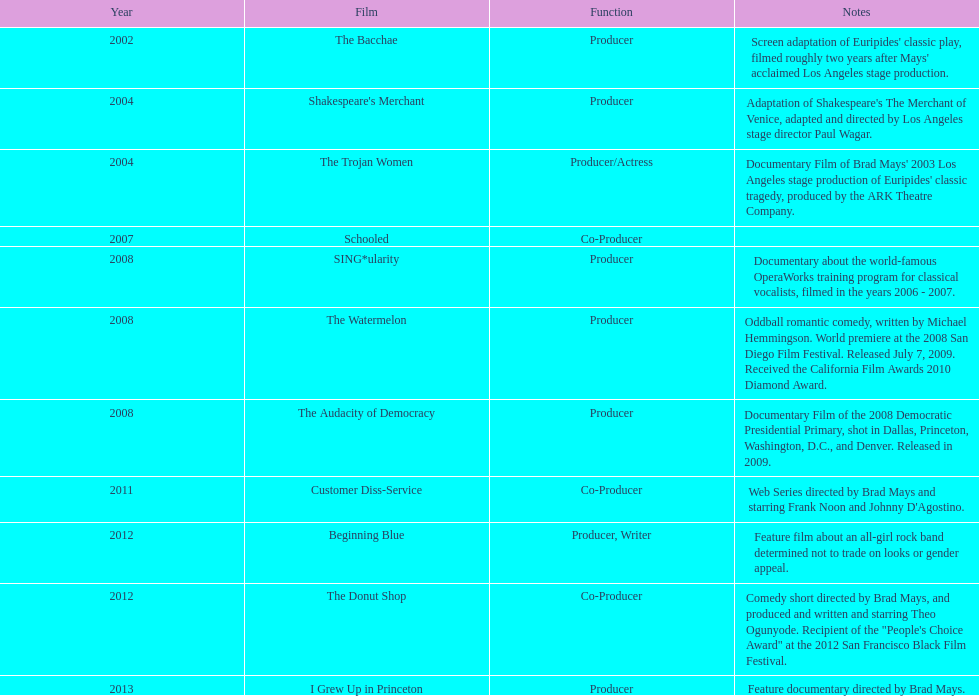What movie preceded the audacity of democracy? The Watermelon. 